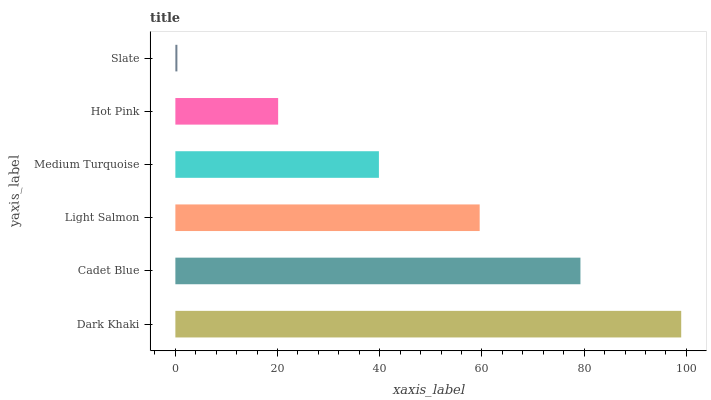Is Slate the minimum?
Answer yes or no. Yes. Is Dark Khaki the maximum?
Answer yes or no. Yes. Is Cadet Blue the minimum?
Answer yes or no. No. Is Cadet Blue the maximum?
Answer yes or no. No. Is Dark Khaki greater than Cadet Blue?
Answer yes or no. Yes. Is Cadet Blue less than Dark Khaki?
Answer yes or no. Yes. Is Cadet Blue greater than Dark Khaki?
Answer yes or no. No. Is Dark Khaki less than Cadet Blue?
Answer yes or no. No. Is Light Salmon the high median?
Answer yes or no. Yes. Is Medium Turquoise the low median?
Answer yes or no. Yes. Is Cadet Blue the high median?
Answer yes or no. No. Is Dark Khaki the low median?
Answer yes or no. No. 